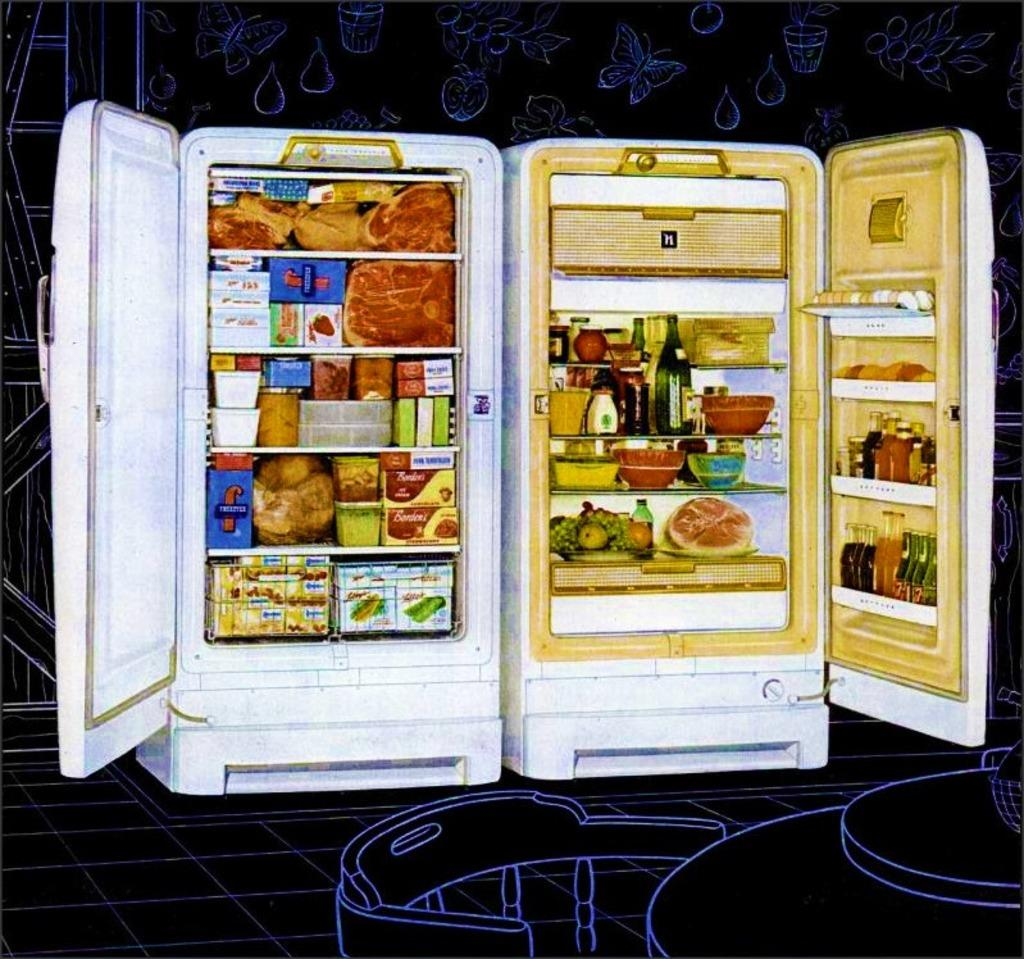How many refrigerators are visible in the image? There are two refrigerators in the image. What is the state of the refrigerator doors? The doors of the refrigerators are open. What type of drawings can be seen in the image? There are drawings of fruits, plants, and insects in the image. What type of zipper is used to close the refrigerator doors in the image? There are no zippers present in the image; the refrigerator doors are opened by handles or knobs. 